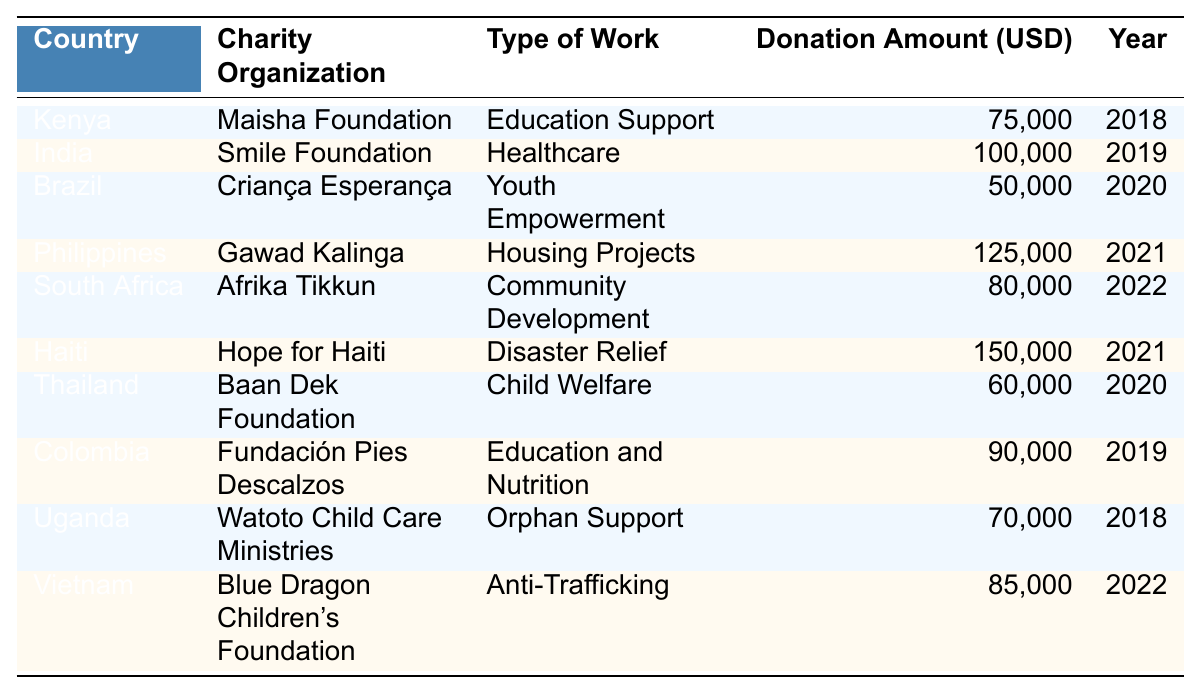What is the total amount donated to charity organizations in Haiti? According to the table, the donation amount for Haiti is listed as 150,000 USD for the year 2021. There is only one entry for Haiti, so the total amount is simply that value.
Answer: 150,000 Which country received the highest donation amount? The entry for the Philippines shows a donation of 125,000 USD for housing projects in 2021, which is the highest in the table. Comparing this with other amounts, the Philippines has the highest donation.
Answer: Philippines - 125,000 How many countries did Laverne Ball donate to in 2020? The table shows three entries for the year 2020: Brazil, Thailand, and the Philippines. Therefore, counting these entries gives us the number of countries she donated to in that year.
Answer: 3 What type of work was supported in India? The entry related to India specifies the charity organization as Smile Foundation and the type of work as Healthcare. So, this is the information directly retrievable from the table.
Answer: Healthcare What is the average donation amount for all countries listed? First, we sum all the donation amounts: 75,000 + 100,000 + 50,000 + 125,000 + 80,000 + 150,000 + 60,000 + 90,000 + 70,000 + 85,000 = 1,010,000 USD. There are 10 entries, so to find the average: 1,010,000 / 10 = 101,000. Therefore, the average donation amount is this result.
Answer: 101,000 Did Laverne Ball donate to any organization focused on education in 2018? Yes, the table shows that Maisha Foundation in Kenya received a donation of 75,000 USD, and it specifically mentions Education Support as the type of work. Hence, the fact confirms that there was a donation aimed at education in 2018.
Answer: Yes Which two countries received donations for youth development initiatives? From the table, we see that Brazil and Kenya have associated charity organizations with youth-related initiatives. Criança Esperança in Brazil focuses on Youth Empowerment, and Maisha Foundation in Kenya is involved in Education Support, indirectly related to youth. Thus, these two countries cater to youth development.
Answer: Brazil and Kenya What is the difference between the highest and the lowest donation amounts? The highest donation amount is 150,000 USD (Haiti), and the lowest is 50,000 USD (Brazil). To find the difference, we subtract the lowest from the highest: 150,000 - 50,000 = 100,000 USD. Therefore, this is the calculated difference.
Answer: 100,000 Which organization worked in Vietnam and what was their focus? According to the table, Blue Dragon Children's Foundation worked in Vietnam, focusing on Anti-Trafficking. This is provided directly in the associated entry for Vietnam.
Answer: Blue Dragon Children's Foundation - Anti-Trafficking In how many years did Laverne Ball focus on projects related to community support? The table specifies one entry for community support in South Africa (80,000 USD, Afrika Tikkun, 2022). This means Laverne Ball focused on community support in only one year according to the data provided.
Answer: 1 